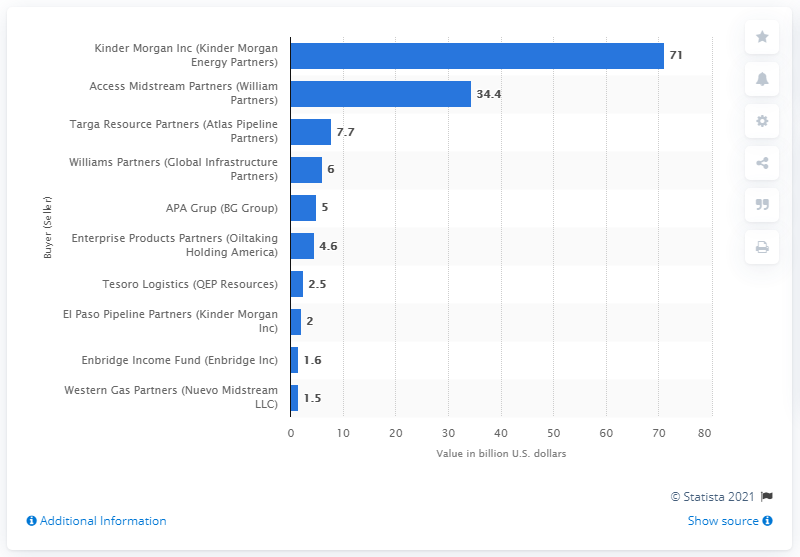List a handful of essential elements in this visual. Williams Partners purchased Global Infrastructure Partners for approximately $6 billion. 